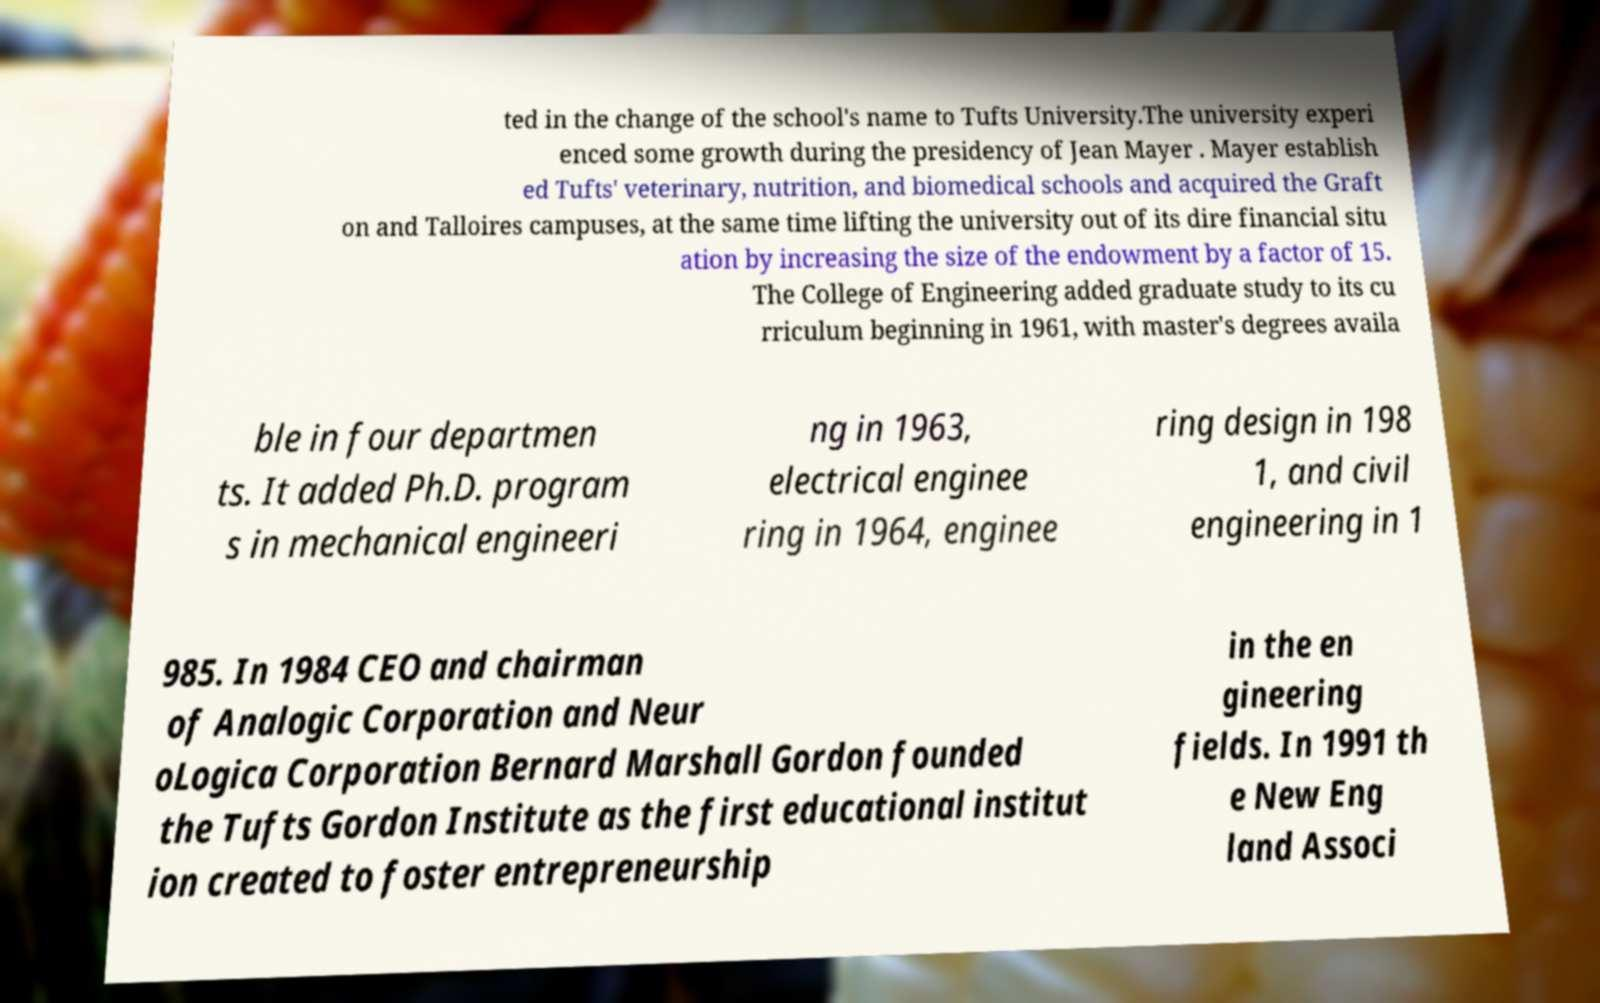Can you accurately transcribe the text from the provided image for me? ted in the change of the school's name to Tufts University.The university experi enced some growth during the presidency of Jean Mayer . Mayer establish ed Tufts' veterinary, nutrition, and biomedical schools and acquired the Graft on and Talloires campuses, at the same time lifting the university out of its dire financial situ ation by increasing the size of the endowment by a factor of 15. The College of Engineering added graduate study to its cu rriculum beginning in 1961, with master's degrees availa ble in four departmen ts. It added Ph.D. program s in mechanical engineeri ng in 1963, electrical enginee ring in 1964, enginee ring design in 198 1, and civil engineering in 1 985. In 1984 CEO and chairman of Analogic Corporation and Neur oLogica Corporation Bernard Marshall Gordon founded the Tufts Gordon Institute as the first educational institut ion created to foster entrepreneurship in the en gineering fields. In 1991 th e New Eng land Associ 